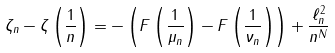<formula> <loc_0><loc_0><loc_500><loc_500>\zeta _ { n } - \zeta \left ( \frac { 1 } { n } \right ) = - \left ( F \left ( \frac { 1 } { \mu _ { n } } \right ) - F \left ( \frac { 1 } { \nu _ { n } } \right ) \right ) + \frac { \ell ^ { 2 } _ { n } } { n ^ { N } }</formula> 